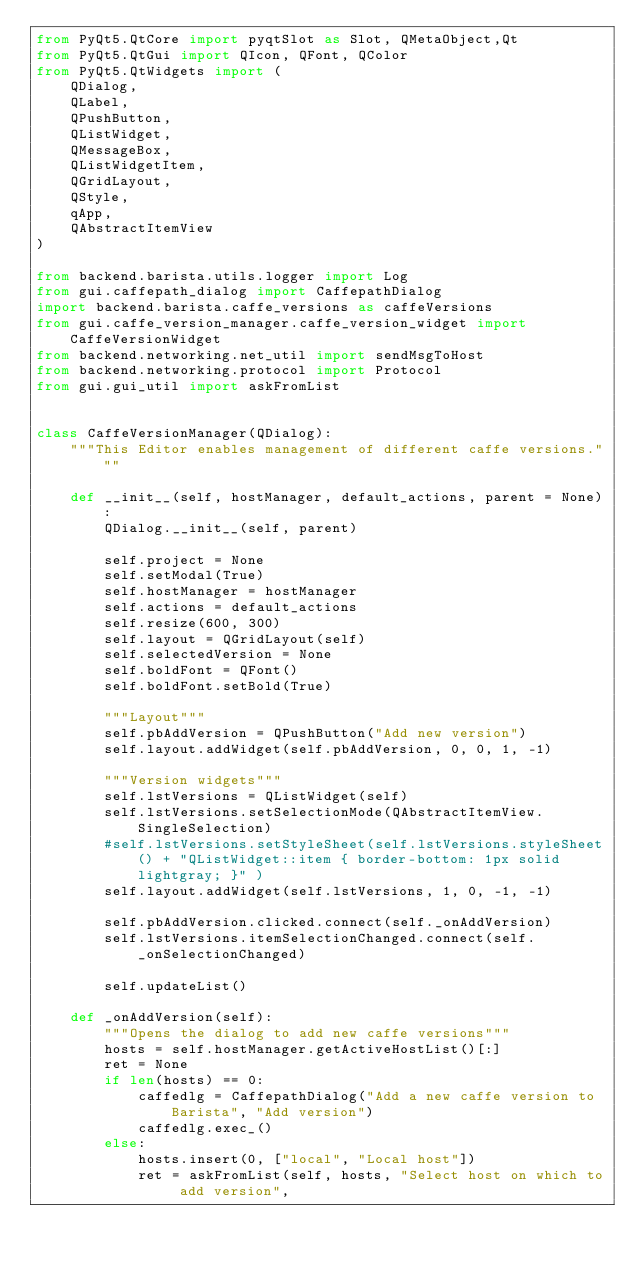<code> <loc_0><loc_0><loc_500><loc_500><_Python_>from PyQt5.QtCore import pyqtSlot as Slot, QMetaObject,Qt
from PyQt5.QtGui import QIcon, QFont, QColor
from PyQt5.QtWidgets import (
    QDialog,
    QLabel,
    QPushButton,
    QListWidget,
    QMessageBox,
    QListWidgetItem,
    QGridLayout,
    QStyle,
    qApp,
    QAbstractItemView
)

from backend.barista.utils.logger import Log
from gui.caffepath_dialog import CaffepathDialog
import backend.barista.caffe_versions as caffeVersions
from gui.caffe_version_manager.caffe_version_widget import CaffeVersionWidget
from backend.networking.net_util import sendMsgToHost
from backend.networking.protocol import Protocol
from gui.gui_util import askFromList


class CaffeVersionManager(QDialog):
    """This Editor enables management of different caffe versions."""

    def __init__(self, hostManager, default_actions, parent = None):
        QDialog.__init__(self, parent)

        self.project = None
        self.setModal(True)
        self.hostManager = hostManager
        self.actions = default_actions
        self.resize(600, 300)
        self.layout = QGridLayout(self)
        self.selectedVersion = None
        self.boldFont = QFont()
        self.boldFont.setBold(True)

        """Layout"""
        self.pbAddVersion = QPushButton("Add new version")
        self.layout.addWidget(self.pbAddVersion, 0, 0, 1, -1)

        """Version widgets"""
        self.lstVersions = QListWidget(self)
        self.lstVersions.setSelectionMode(QAbstractItemView.SingleSelection)
        #self.lstVersions.setStyleSheet(self.lstVersions.styleSheet() + "QListWidget::item { border-bottom: 1px solid lightgray; }" )
        self.layout.addWidget(self.lstVersions, 1, 0, -1, -1)

        self.pbAddVersion.clicked.connect(self._onAddVersion)
        self.lstVersions.itemSelectionChanged.connect(self._onSelectionChanged)

        self.updateList()
        
    def _onAddVersion(self):
        """Opens the dialog to add new caffe versions"""
        hosts = self.hostManager.getActiveHostList()[:]
        ret = None
        if len(hosts) == 0:
            caffedlg = CaffepathDialog("Add a new caffe version to Barista", "Add version")
            caffedlg.exec_()
        else:
            hosts.insert(0, ["local", "Local host"])
            ret = askFromList(self, hosts, "Select host on which to add version",</code> 